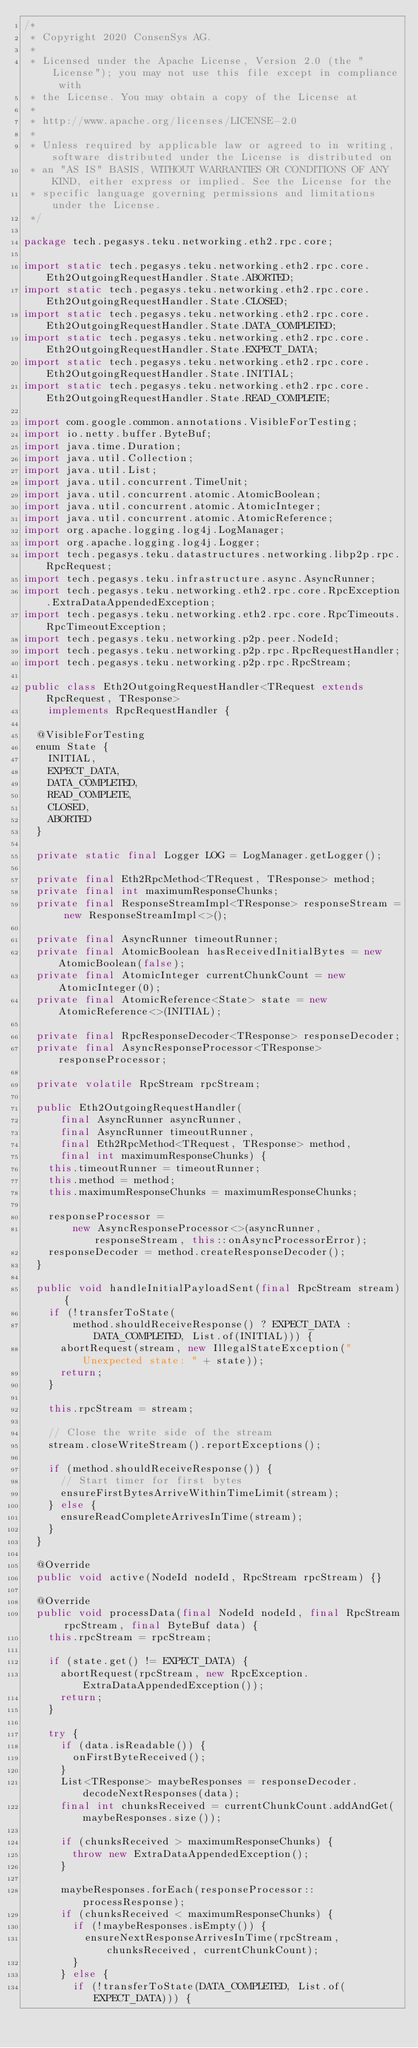Convert code to text. <code><loc_0><loc_0><loc_500><loc_500><_Java_>/*
 * Copyright 2020 ConsenSys AG.
 *
 * Licensed under the Apache License, Version 2.0 (the "License"); you may not use this file except in compliance with
 * the License. You may obtain a copy of the License at
 *
 * http://www.apache.org/licenses/LICENSE-2.0
 *
 * Unless required by applicable law or agreed to in writing, software distributed under the License is distributed on
 * an "AS IS" BASIS, WITHOUT WARRANTIES OR CONDITIONS OF ANY KIND, either express or implied. See the License for the
 * specific language governing permissions and limitations under the License.
 */

package tech.pegasys.teku.networking.eth2.rpc.core;

import static tech.pegasys.teku.networking.eth2.rpc.core.Eth2OutgoingRequestHandler.State.ABORTED;
import static tech.pegasys.teku.networking.eth2.rpc.core.Eth2OutgoingRequestHandler.State.CLOSED;
import static tech.pegasys.teku.networking.eth2.rpc.core.Eth2OutgoingRequestHandler.State.DATA_COMPLETED;
import static tech.pegasys.teku.networking.eth2.rpc.core.Eth2OutgoingRequestHandler.State.EXPECT_DATA;
import static tech.pegasys.teku.networking.eth2.rpc.core.Eth2OutgoingRequestHandler.State.INITIAL;
import static tech.pegasys.teku.networking.eth2.rpc.core.Eth2OutgoingRequestHandler.State.READ_COMPLETE;

import com.google.common.annotations.VisibleForTesting;
import io.netty.buffer.ByteBuf;
import java.time.Duration;
import java.util.Collection;
import java.util.List;
import java.util.concurrent.TimeUnit;
import java.util.concurrent.atomic.AtomicBoolean;
import java.util.concurrent.atomic.AtomicInteger;
import java.util.concurrent.atomic.AtomicReference;
import org.apache.logging.log4j.LogManager;
import org.apache.logging.log4j.Logger;
import tech.pegasys.teku.datastructures.networking.libp2p.rpc.RpcRequest;
import tech.pegasys.teku.infrastructure.async.AsyncRunner;
import tech.pegasys.teku.networking.eth2.rpc.core.RpcException.ExtraDataAppendedException;
import tech.pegasys.teku.networking.eth2.rpc.core.RpcTimeouts.RpcTimeoutException;
import tech.pegasys.teku.networking.p2p.peer.NodeId;
import tech.pegasys.teku.networking.p2p.rpc.RpcRequestHandler;
import tech.pegasys.teku.networking.p2p.rpc.RpcStream;

public class Eth2OutgoingRequestHandler<TRequest extends RpcRequest, TResponse>
    implements RpcRequestHandler {

  @VisibleForTesting
  enum State {
    INITIAL,
    EXPECT_DATA,
    DATA_COMPLETED,
    READ_COMPLETE,
    CLOSED,
    ABORTED
  }

  private static final Logger LOG = LogManager.getLogger();

  private final Eth2RpcMethod<TRequest, TResponse> method;
  private final int maximumResponseChunks;
  private final ResponseStreamImpl<TResponse> responseStream = new ResponseStreamImpl<>();

  private final AsyncRunner timeoutRunner;
  private final AtomicBoolean hasReceivedInitialBytes = new AtomicBoolean(false);
  private final AtomicInteger currentChunkCount = new AtomicInteger(0);
  private final AtomicReference<State> state = new AtomicReference<>(INITIAL);

  private final RpcResponseDecoder<TResponse> responseDecoder;
  private final AsyncResponseProcessor<TResponse> responseProcessor;

  private volatile RpcStream rpcStream;

  public Eth2OutgoingRequestHandler(
      final AsyncRunner asyncRunner,
      final AsyncRunner timeoutRunner,
      final Eth2RpcMethod<TRequest, TResponse> method,
      final int maximumResponseChunks) {
    this.timeoutRunner = timeoutRunner;
    this.method = method;
    this.maximumResponseChunks = maximumResponseChunks;

    responseProcessor =
        new AsyncResponseProcessor<>(asyncRunner, responseStream, this::onAsyncProcessorError);
    responseDecoder = method.createResponseDecoder();
  }

  public void handleInitialPayloadSent(final RpcStream stream) {
    if (!transferToState(
        method.shouldReceiveResponse() ? EXPECT_DATA : DATA_COMPLETED, List.of(INITIAL))) {
      abortRequest(stream, new IllegalStateException("Unexpected state: " + state));
      return;
    }

    this.rpcStream = stream;

    // Close the write side of the stream
    stream.closeWriteStream().reportExceptions();

    if (method.shouldReceiveResponse()) {
      // Start timer for first bytes
      ensureFirstBytesArriveWithinTimeLimit(stream);
    } else {
      ensureReadCompleteArrivesInTime(stream);
    }
  }

  @Override
  public void active(NodeId nodeId, RpcStream rpcStream) {}

  @Override
  public void processData(final NodeId nodeId, final RpcStream rpcStream, final ByteBuf data) {
    this.rpcStream = rpcStream;

    if (state.get() != EXPECT_DATA) {
      abortRequest(rpcStream, new RpcException.ExtraDataAppendedException());
      return;
    }

    try {
      if (data.isReadable()) {
        onFirstByteReceived();
      }
      List<TResponse> maybeResponses = responseDecoder.decodeNextResponses(data);
      final int chunksReceived = currentChunkCount.addAndGet(maybeResponses.size());

      if (chunksReceived > maximumResponseChunks) {
        throw new ExtraDataAppendedException();
      }

      maybeResponses.forEach(responseProcessor::processResponse);
      if (chunksReceived < maximumResponseChunks) {
        if (!maybeResponses.isEmpty()) {
          ensureNextResponseArrivesInTime(rpcStream, chunksReceived, currentChunkCount);
        }
      } else {
        if (!transferToState(DATA_COMPLETED, List.of(EXPECT_DATA))) {</code> 